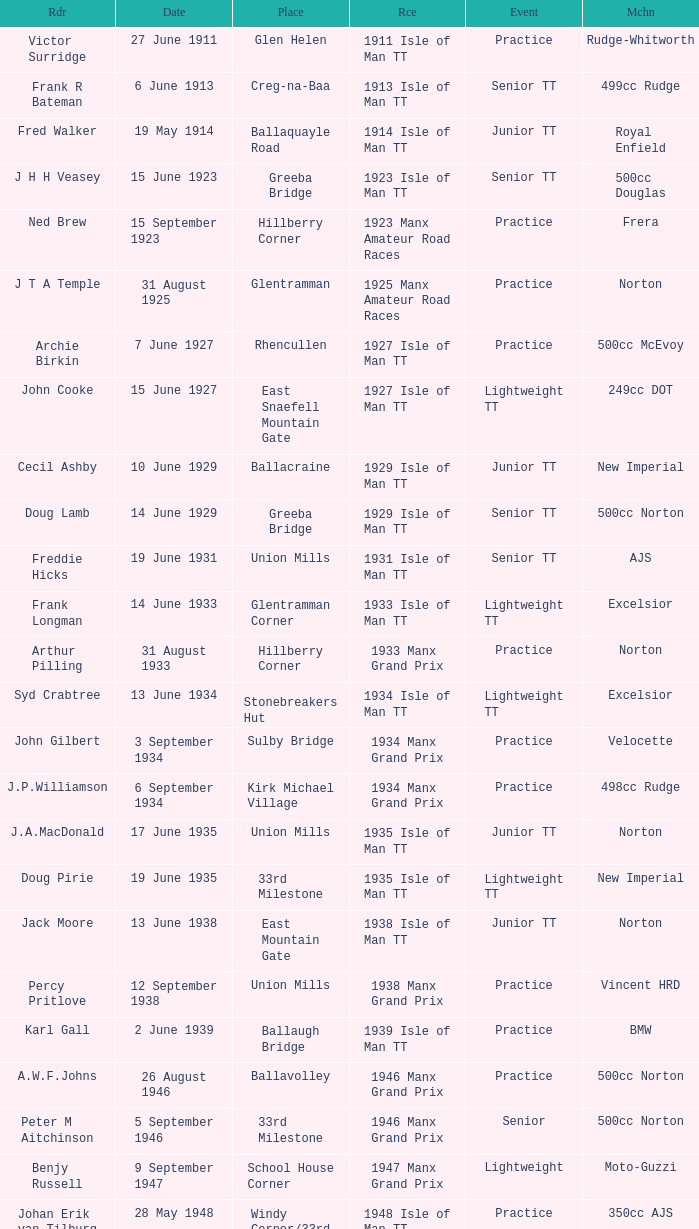What machine did Keith T. Gawler ride? 499cc Norton. 